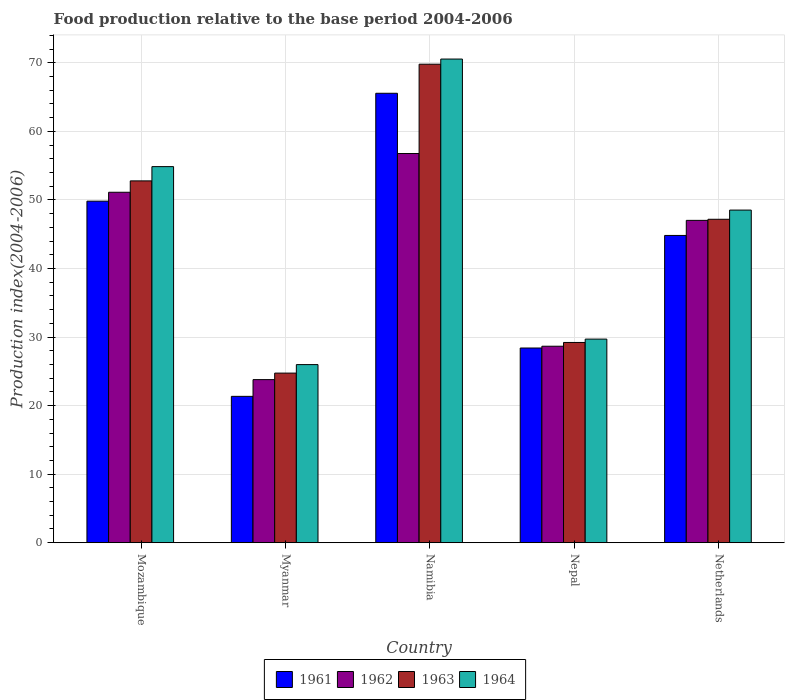How many groups of bars are there?
Give a very brief answer. 5. Are the number of bars on each tick of the X-axis equal?
Provide a short and direct response. Yes. How many bars are there on the 3rd tick from the right?
Your answer should be compact. 4. What is the label of the 5th group of bars from the left?
Your response must be concise. Netherlands. In how many cases, is the number of bars for a given country not equal to the number of legend labels?
Provide a succinct answer. 0. What is the food production index in 1961 in Myanmar?
Provide a succinct answer. 21.35. Across all countries, what is the maximum food production index in 1961?
Keep it short and to the point. 65.56. Across all countries, what is the minimum food production index in 1962?
Keep it short and to the point. 23.79. In which country was the food production index in 1963 maximum?
Your answer should be compact. Namibia. In which country was the food production index in 1962 minimum?
Provide a succinct answer. Myanmar. What is the total food production index in 1963 in the graph?
Offer a very short reply. 223.71. What is the difference between the food production index in 1963 in Namibia and that in Nepal?
Provide a short and direct response. 40.59. What is the difference between the food production index in 1964 in Mozambique and the food production index in 1962 in Namibia?
Ensure brevity in your answer.  -1.91. What is the average food production index in 1961 per country?
Provide a succinct answer. 41.99. What is the difference between the food production index of/in 1961 and food production index of/in 1962 in Nepal?
Your answer should be compact. -0.26. In how many countries, is the food production index in 1961 greater than 4?
Ensure brevity in your answer.  5. What is the ratio of the food production index in 1961 in Namibia to that in Nepal?
Offer a very short reply. 2.31. What is the difference between the highest and the second highest food production index in 1963?
Your response must be concise. -17.02. What is the difference between the highest and the lowest food production index in 1962?
Your response must be concise. 32.98. In how many countries, is the food production index in 1964 greater than the average food production index in 1964 taken over all countries?
Provide a succinct answer. 3. What does the 4th bar from the left in Namibia represents?
Your answer should be very brief. 1964. Is it the case that in every country, the sum of the food production index in 1964 and food production index in 1962 is greater than the food production index in 1961?
Your answer should be compact. Yes. Are all the bars in the graph horizontal?
Your answer should be very brief. No. What is the difference between two consecutive major ticks on the Y-axis?
Make the answer very short. 10. Are the values on the major ticks of Y-axis written in scientific E-notation?
Provide a short and direct response. No. Does the graph contain any zero values?
Provide a succinct answer. No. Does the graph contain grids?
Ensure brevity in your answer.  Yes. How many legend labels are there?
Ensure brevity in your answer.  4. What is the title of the graph?
Offer a very short reply. Food production relative to the base period 2004-2006. What is the label or title of the Y-axis?
Offer a very short reply. Production index(2004-2006). What is the Production index(2004-2006) of 1961 in Mozambique?
Provide a succinct answer. 49.82. What is the Production index(2004-2006) in 1962 in Mozambique?
Make the answer very short. 51.12. What is the Production index(2004-2006) in 1963 in Mozambique?
Your answer should be compact. 52.78. What is the Production index(2004-2006) in 1964 in Mozambique?
Provide a short and direct response. 54.86. What is the Production index(2004-2006) of 1961 in Myanmar?
Keep it short and to the point. 21.35. What is the Production index(2004-2006) in 1962 in Myanmar?
Offer a very short reply. 23.79. What is the Production index(2004-2006) in 1963 in Myanmar?
Give a very brief answer. 24.74. What is the Production index(2004-2006) of 1964 in Myanmar?
Offer a terse response. 25.98. What is the Production index(2004-2006) in 1961 in Namibia?
Keep it short and to the point. 65.56. What is the Production index(2004-2006) in 1962 in Namibia?
Provide a succinct answer. 56.77. What is the Production index(2004-2006) in 1963 in Namibia?
Offer a very short reply. 69.8. What is the Production index(2004-2006) in 1964 in Namibia?
Offer a very short reply. 70.55. What is the Production index(2004-2006) of 1961 in Nepal?
Give a very brief answer. 28.4. What is the Production index(2004-2006) of 1962 in Nepal?
Provide a succinct answer. 28.66. What is the Production index(2004-2006) in 1963 in Nepal?
Offer a very short reply. 29.21. What is the Production index(2004-2006) in 1964 in Nepal?
Offer a terse response. 29.7. What is the Production index(2004-2006) in 1961 in Netherlands?
Provide a succinct answer. 44.82. What is the Production index(2004-2006) in 1962 in Netherlands?
Your answer should be very brief. 47.02. What is the Production index(2004-2006) in 1963 in Netherlands?
Your response must be concise. 47.18. What is the Production index(2004-2006) of 1964 in Netherlands?
Provide a short and direct response. 48.52. Across all countries, what is the maximum Production index(2004-2006) of 1961?
Ensure brevity in your answer.  65.56. Across all countries, what is the maximum Production index(2004-2006) in 1962?
Provide a short and direct response. 56.77. Across all countries, what is the maximum Production index(2004-2006) of 1963?
Provide a succinct answer. 69.8. Across all countries, what is the maximum Production index(2004-2006) of 1964?
Make the answer very short. 70.55. Across all countries, what is the minimum Production index(2004-2006) of 1961?
Ensure brevity in your answer.  21.35. Across all countries, what is the minimum Production index(2004-2006) of 1962?
Ensure brevity in your answer.  23.79. Across all countries, what is the minimum Production index(2004-2006) of 1963?
Give a very brief answer. 24.74. Across all countries, what is the minimum Production index(2004-2006) in 1964?
Your response must be concise. 25.98. What is the total Production index(2004-2006) in 1961 in the graph?
Ensure brevity in your answer.  209.95. What is the total Production index(2004-2006) in 1962 in the graph?
Your answer should be very brief. 207.36. What is the total Production index(2004-2006) in 1963 in the graph?
Provide a short and direct response. 223.71. What is the total Production index(2004-2006) of 1964 in the graph?
Offer a very short reply. 229.61. What is the difference between the Production index(2004-2006) in 1961 in Mozambique and that in Myanmar?
Your answer should be compact. 28.47. What is the difference between the Production index(2004-2006) in 1962 in Mozambique and that in Myanmar?
Ensure brevity in your answer.  27.33. What is the difference between the Production index(2004-2006) in 1963 in Mozambique and that in Myanmar?
Provide a succinct answer. 28.04. What is the difference between the Production index(2004-2006) of 1964 in Mozambique and that in Myanmar?
Your answer should be compact. 28.88. What is the difference between the Production index(2004-2006) of 1961 in Mozambique and that in Namibia?
Your answer should be very brief. -15.74. What is the difference between the Production index(2004-2006) in 1962 in Mozambique and that in Namibia?
Give a very brief answer. -5.65. What is the difference between the Production index(2004-2006) in 1963 in Mozambique and that in Namibia?
Your answer should be very brief. -17.02. What is the difference between the Production index(2004-2006) in 1964 in Mozambique and that in Namibia?
Provide a succinct answer. -15.69. What is the difference between the Production index(2004-2006) of 1961 in Mozambique and that in Nepal?
Your answer should be compact. 21.42. What is the difference between the Production index(2004-2006) of 1962 in Mozambique and that in Nepal?
Ensure brevity in your answer.  22.46. What is the difference between the Production index(2004-2006) of 1963 in Mozambique and that in Nepal?
Provide a succinct answer. 23.57. What is the difference between the Production index(2004-2006) of 1964 in Mozambique and that in Nepal?
Keep it short and to the point. 25.16. What is the difference between the Production index(2004-2006) of 1962 in Mozambique and that in Netherlands?
Keep it short and to the point. 4.1. What is the difference between the Production index(2004-2006) in 1963 in Mozambique and that in Netherlands?
Your answer should be very brief. 5.6. What is the difference between the Production index(2004-2006) in 1964 in Mozambique and that in Netherlands?
Give a very brief answer. 6.34. What is the difference between the Production index(2004-2006) of 1961 in Myanmar and that in Namibia?
Your answer should be very brief. -44.21. What is the difference between the Production index(2004-2006) of 1962 in Myanmar and that in Namibia?
Offer a terse response. -32.98. What is the difference between the Production index(2004-2006) of 1963 in Myanmar and that in Namibia?
Your answer should be very brief. -45.06. What is the difference between the Production index(2004-2006) in 1964 in Myanmar and that in Namibia?
Your answer should be very brief. -44.57. What is the difference between the Production index(2004-2006) of 1961 in Myanmar and that in Nepal?
Your answer should be very brief. -7.05. What is the difference between the Production index(2004-2006) of 1962 in Myanmar and that in Nepal?
Offer a very short reply. -4.87. What is the difference between the Production index(2004-2006) in 1963 in Myanmar and that in Nepal?
Your response must be concise. -4.47. What is the difference between the Production index(2004-2006) in 1964 in Myanmar and that in Nepal?
Provide a succinct answer. -3.72. What is the difference between the Production index(2004-2006) of 1961 in Myanmar and that in Netherlands?
Your response must be concise. -23.47. What is the difference between the Production index(2004-2006) in 1962 in Myanmar and that in Netherlands?
Keep it short and to the point. -23.23. What is the difference between the Production index(2004-2006) in 1963 in Myanmar and that in Netherlands?
Provide a short and direct response. -22.44. What is the difference between the Production index(2004-2006) of 1964 in Myanmar and that in Netherlands?
Keep it short and to the point. -22.54. What is the difference between the Production index(2004-2006) in 1961 in Namibia and that in Nepal?
Offer a very short reply. 37.16. What is the difference between the Production index(2004-2006) of 1962 in Namibia and that in Nepal?
Keep it short and to the point. 28.11. What is the difference between the Production index(2004-2006) in 1963 in Namibia and that in Nepal?
Your answer should be very brief. 40.59. What is the difference between the Production index(2004-2006) of 1964 in Namibia and that in Nepal?
Your answer should be very brief. 40.85. What is the difference between the Production index(2004-2006) of 1961 in Namibia and that in Netherlands?
Your answer should be compact. 20.74. What is the difference between the Production index(2004-2006) in 1962 in Namibia and that in Netherlands?
Your answer should be compact. 9.75. What is the difference between the Production index(2004-2006) of 1963 in Namibia and that in Netherlands?
Provide a short and direct response. 22.62. What is the difference between the Production index(2004-2006) in 1964 in Namibia and that in Netherlands?
Make the answer very short. 22.03. What is the difference between the Production index(2004-2006) of 1961 in Nepal and that in Netherlands?
Your answer should be very brief. -16.42. What is the difference between the Production index(2004-2006) in 1962 in Nepal and that in Netherlands?
Your answer should be very brief. -18.36. What is the difference between the Production index(2004-2006) of 1963 in Nepal and that in Netherlands?
Offer a terse response. -17.97. What is the difference between the Production index(2004-2006) of 1964 in Nepal and that in Netherlands?
Provide a succinct answer. -18.82. What is the difference between the Production index(2004-2006) in 1961 in Mozambique and the Production index(2004-2006) in 1962 in Myanmar?
Your response must be concise. 26.03. What is the difference between the Production index(2004-2006) in 1961 in Mozambique and the Production index(2004-2006) in 1963 in Myanmar?
Keep it short and to the point. 25.08. What is the difference between the Production index(2004-2006) of 1961 in Mozambique and the Production index(2004-2006) of 1964 in Myanmar?
Offer a very short reply. 23.84. What is the difference between the Production index(2004-2006) of 1962 in Mozambique and the Production index(2004-2006) of 1963 in Myanmar?
Offer a very short reply. 26.38. What is the difference between the Production index(2004-2006) of 1962 in Mozambique and the Production index(2004-2006) of 1964 in Myanmar?
Your answer should be very brief. 25.14. What is the difference between the Production index(2004-2006) in 1963 in Mozambique and the Production index(2004-2006) in 1964 in Myanmar?
Give a very brief answer. 26.8. What is the difference between the Production index(2004-2006) of 1961 in Mozambique and the Production index(2004-2006) of 1962 in Namibia?
Your response must be concise. -6.95. What is the difference between the Production index(2004-2006) of 1961 in Mozambique and the Production index(2004-2006) of 1963 in Namibia?
Offer a terse response. -19.98. What is the difference between the Production index(2004-2006) in 1961 in Mozambique and the Production index(2004-2006) in 1964 in Namibia?
Your answer should be compact. -20.73. What is the difference between the Production index(2004-2006) in 1962 in Mozambique and the Production index(2004-2006) in 1963 in Namibia?
Keep it short and to the point. -18.68. What is the difference between the Production index(2004-2006) in 1962 in Mozambique and the Production index(2004-2006) in 1964 in Namibia?
Your response must be concise. -19.43. What is the difference between the Production index(2004-2006) of 1963 in Mozambique and the Production index(2004-2006) of 1964 in Namibia?
Make the answer very short. -17.77. What is the difference between the Production index(2004-2006) in 1961 in Mozambique and the Production index(2004-2006) in 1962 in Nepal?
Make the answer very short. 21.16. What is the difference between the Production index(2004-2006) in 1961 in Mozambique and the Production index(2004-2006) in 1963 in Nepal?
Your answer should be very brief. 20.61. What is the difference between the Production index(2004-2006) of 1961 in Mozambique and the Production index(2004-2006) of 1964 in Nepal?
Make the answer very short. 20.12. What is the difference between the Production index(2004-2006) in 1962 in Mozambique and the Production index(2004-2006) in 1963 in Nepal?
Offer a terse response. 21.91. What is the difference between the Production index(2004-2006) of 1962 in Mozambique and the Production index(2004-2006) of 1964 in Nepal?
Provide a short and direct response. 21.42. What is the difference between the Production index(2004-2006) in 1963 in Mozambique and the Production index(2004-2006) in 1964 in Nepal?
Give a very brief answer. 23.08. What is the difference between the Production index(2004-2006) of 1961 in Mozambique and the Production index(2004-2006) of 1962 in Netherlands?
Provide a short and direct response. 2.8. What is the difference between the Production index(2004-2006) in 1961 in Mozambique and the Production index(2004-2006) in 1963 in Netherlands?
Your answer should be compact. 2.64. What is the difference between the Production index(2004-2006) in 1962 in Mozambique and the Production index(2004-2006) in 1963 in Netherlands?
Your answer should be compact. 3.94. What is the difference between the Production index(2004-2006) in 1962 in Mozambique and the Production index(2004-2006) in 1964 in Netherlands?
Give a very brief answer. 2.6. What is the difference between the Production index(2004-2006) in 1963 in Mozambique and the Production index(2004-2006) in 1964 in Netherlands?
Provide a succinct answer. 4.26. What is the difference between the Production index(2004-2006) in 1961 in Myanmar and the Production index(2004-2006) in 1962 in Namibia?
Keep it short and to the point. -35.42. What is the difference between the Production index(2004-2006) in 1961 in Myanmar and the Production index(2004-2006) in 1963 in Namibia?
Keep it short and to the point. -48.45. What is the difference between the Production index(2004-2006) in 1961 in Myanmar and the Production index(2004-2006) in 1964 in Namibia?
Keep it short and to the point. -49.2. What is the difference between the Production index(2004-2006) in 1962 in Myanmar and the Production index(2004-2006) in 1963 in Namibia?
Your answer should be very brief. -46.01. What is the difference between the Production index(2004-2006) in 1962 in Myanmar and the Production index(2004-2006) in 1964 in Namibia?
Keep it short and to the point. -46.76. What is the difference between the Production index(2004-2006) in 1963 in Myanmar and the Production index(2004-2006) in 1964 in Namibia?
Your response must be concise. -45.81. What is the difference between the Production index(2004-2006) of 1961 in Myanmar and the Production index(2004-2006) of 1962 in Nepal?
Give a very brief answer. -7.31. What is the difference between the Production index(2004-2006) of 1961 in Myanmar and the Production index(2004-2006) of 1963 in Nepal?
Your answer should be compact. -7.86. What is the difference between the Production index(2004-2006) in 1961 in Myanmar and the Production index(2004-2006) in 1964 in Nepal?
Your response must be concise. -8.35. What is the difference between the Production index(2004-2006) of 1962 in Myanmar and the Production index(2004-2006) of 1963 in Nepal?
Give a very brief answer. -5.42. What is the difference between the Production index(2004-2006) in 1962 in Myanmar and the Production index(2004-2006) in 1964 in Nepal?
Give a very brief answer. -5.91. What is the difference between the Production index(2004-2006) of 1963 in Myanmar and the Production index(2004-2006) of 1964 in Nepal?
Make the answer very short. -4.96. What is the difference between the Production index(2004-2006) of 1961 in Myanmar and the Production index(2004-2006) of 1962 in Netherlands?
Ensure brevity in your answer.  -25.67. What is the difference between the Production index(2004-2006) of 1961 in Myanmar and the Production index(2004-2006) of 1963 in Netherlands?
Your response must be concise. -25.83. What is the difference between the Production index(2004-2006) of 1961 in Myanmar and the Production index(2004-2006) of 1964 in Netherlands?
Offer a terse response. -27.17. What is the difference between the Production index(2004-2006) in 1962 in Myanmar and the Production index(2004-2006) in 1963 in Netherlands?
Your answer should be compact. -23.39. What is the difference between the Production index(2004-2006) in 1962 in Myanmar and the Production index(2004-2006) in 1964 in Netherlands?
Your answer should be very brief. -24.73. What is the difference between the Production index(2004-2006) in 1963 in Myanmar and the Production index(2004-2006) in 1964 in Netherlands?
Provide a succinct answer. -23.78. What is the difference between the Production index(2004-2006) in 1961 in Namibia and the Production index(2004-2006) in 1962 in Nepal?
Keep it short and to the point. 36.9. What is the difference between the Production index(2004-2006) of 1961 in Namibia and the Production index(2004-2006) of 1963 in Nepal?
Your answer should be very brief. 36.35. What is the difference between the Production index(2004-2006) in 1961 in Namibia and the Production index(2004-2006) in 1964 in Nepal?
Your answer should be very brief. 35.86. What is the difference between the Production index(2004-2006) of 1962 in Namibia and the Production index(2004-2006) of 1963 in Nepal?
Your answer should be compact. 27.56. What is the difference between the Production index(2004-2006) in 1962 in Namibia and the Production index(2004-2006) in 1964 in Nepal?
Keep it short and to the point. 27.07. What is the difference between the Production index(2004-2006) in 1963 in Namibia and the Production index(2004-2006) in 1964 in Nepal?
Your answer should be very brief. 40.1. What is the difference between the Production index(2004-2006) in 1961 in Namibia and the Production index(2004-2006) in 1962 in Netherlands?
Your answer should be compact. 18.54. What is the difference between the Production index(2004-2006) of 1961 in Namibia and the Production index(2004-2006) of 1963 in Netherlands?
Your answer should be very brief. 18.38. What is the difference between the Production index(2004-2006) of 1961 in Namibia and the Production index(2004-2006) of 1964 in Netherlands?
Give a very brief answer. 17.04. What is the difference between the Production index(2004-2006) of 1962 in Namibia and the Production index(2004-2006) of 1963 in Netherlands?
Your answer should be very brief. 9.59. What is the difference between the Production index(2004-2006) in 1962 in Namibia and the Production index(2004-2006) in 1964 in Netherlands?
Give a very brief answer. 8.25. What is the difference between the Production index(2004-2006) in 1963 in Namibia and the Production index(2004-2006) in 1964 in Netherlands?
Give a very brief answer. 21.28. What is the difference between the Production index(2004-2006) of 1961 in Nepal and the Production index(2004-2006) of 1962 in Netherlands?
Offer a very short reply. -18.62. What is the difference between the Production index(2004-2006) of 1961 in Nepal and the Production index(2004-2006) of 1963 in Netherlands?
Keep it short and to the point. -18.78. What is the difference between the Production index(2004-2006) of 1961 in Nepal and the Production index(2004-2006) of 1964 in Netherlands?
Keep it short and to the point. -20.12. What is the difference between the Production index(2004-2006) of 1962 in Nepal and the Production index(2004-2006) of 1963 in Netherlands?
Make the answer very short. -18.52. What is the difference between the Production index(2004-2006) of 1962 in Nepal and the Production index(2004-2006) of 1964 in Netherlands?
Offer a terse response. -19.86. What is the difference between the Production index(2004-2006) of 1963 in Nepal and the Production index(2004-2006) of 1964 in Netherlands?
Make the answer very short. -19.31. What is the average Production index(2004-2006) of 1961 per country?
Provide a short and direct response. 41.99. What is the average Production index(2004-2006) of 1962 per country?
Your answer should be very brief. 41.47. What is the average Production index(2004-2006) of 1963 per country?
Provide a short and direct response. 44.74. What is the average Production index(2004-2006) in 1964 per country?
Your response must be concise. 45.92. What is the difference between the Production index(2004-2006) in 1961 and Production index(2004-2006) in 1962 in Mozambique?
Ensure brevity in your answer.  -1.3. What is the difference between the Production index(2004-2006) in 1961 and Production index(2004-2006) in 1963 in Mozambique?
Ensure brevity in your answer.  -2.96. What is the difference between the Production index(2004-2006) in 1961 and Production index(2004-2006) in 1964 in Mozambique?
Your response must be concise. -5.04. What is the difference between the Production index(2004-2006) of 1962 and Production index(2004-2006) of 1963 in Mozambique?
Keep it short and to the point. -1.66. What is the difference between the Production index(2004-2006) in 1962 and Production index(2004-2006) in 1964 in Mozambique?
Your answer should be very brief. -3.74. What is the difference between the Production index(2004-2006) in 1963 and Production index(2004-2006) in 1964 in Mozambique?
Provide a short and direct response. -2.08. What is the difference between the Production index(2004-2006) in 1961 and Production index(2004-2006) in 1962 in Myanmar?
Your answer should be compact. -2.44. What is the difference between the Production index(2004-2006) in 1961 and Production index(2004-2006) in 1963 in Myanmar?
Provide a succinct answer. -3.39. What is the difference between the Production index(2004-2006) of 1961 and Production index(2004-2006) of 1964 in Myanmar?
Your response must be concise. -4.63. What is the difference between the Production index(2004-2006) of 1962 and Production index(2004-2006) of 1963 in Myanmar?
Offer a very short reply. -0.95. What is the difference between the Production index(2004-2006) of 1962 and Production index(2004-2006) of 1964 in Myanmar?
Keep it short and to the point. -2.19. What is the difference between the Production index(2004-2006) of 1963 and Production index(2004-2006) of 1964 in Myanmar?
Provide a succinct answer. -1.24. What is the difference between the Production index(2004-2006) in 1961 and Production index(2004-2006) in 1962 in Namibia?
Your answer should be compact. 8.79. What is the difference between the Production index(2004-2006) in 1961 and Production index(2004-2006) in 1963 in Namibia?
Provide a succinct answer. -4.24. What is the difference between the Production index(2004-2006) in 1961 and Production index(2004-2006) in 1964 in Namibia?
Keep it short and to the point. -4.99. What is the difference between the Production index(2004-2006) in 1962 and Production index(2004-2006) in 1963 in Namibia?
Your answer should be compact. -13.03. What is the difference between the Production index(2004-2006) of 1962 and Production index(2004-2006) of 1964 in Namibia?
Ensure brevity in your answer.  -13.78. What is the difference between the Production index(2004-2006) of 1963 and Production index(2004-2006) of 1964 in Namibia?
Your response must be concise. -0.75. What is the difference between the Production index(2004-2006) of 1961 and Production index(2004-2006) of 1962 in Nepal?
Ensure brevity in your answer.  -0.26. What is the difference between the Production index(2004-2006) in 1961 and Production index(2004-2006) in 1963 in Nepal?
Keep it short and to the point. -0.81. What is the difference between the Production index(2004-2006) in 1962 and Production index(2004-2006) in 1963 in Nepal?
Your answer should be compact. -0.55. What is the difference between the Production index(2004-2006) of 1962 and Production index(2004-2006) of 1964 in Nepal?
Your response must be concise. -1.04. What is the difference between the Production index(2004-2006) of 1963 and Production index(2004-2006) of 1964 in Nepal?
Your response must be concise. -0.49. What is the difference between the Production index(2004-2006) of 1961 and Production index(2004-2006) of 1962 in Netherlands?
Keep it short and to the point. -2.2. What is the difference between the Production index(2004-2006) of 1961 and Production index(2004-2006) of 1963 in Netherlands?
Your answer should be very brief. -2.36. What is the difference between the Production index(2004-2006) of 1962 and Production index(2004-2006) of 1963 in Netherlands?
Your answer should be very brief. -0.16. What is the difference between the Production index(2004-2006) in 1962 and Production index(2004-2006) in 1964 in Netherlands?
Provide a succinct answer. -1.5. What is the difference between the Production index(2004-2006) in 1963 and Production index(2004-2006) in 1964 in Netherlands?
Your answer should be very brief. -1.34. What is the ratio of the Production index(2004-2006) of 1961 in Mozambique to that in Myanmar?
Give a very brief answer. 2.33. What is the ratio of the Production index(2004-2006) of 1962 in Mozambique to that in Myanmar?
Give a very brief answer. 2.15. What is the ratio of the Production index(2004-2006) of 1963 in Mozambique to that in Myanmar?
Ensure brevity in your answer.  2.13. What is the ratio of the Production index(2004-2006) of 1964 in Mozambique to that in Myanmar?
Your response must be concise. 2.11. What is the ratio of the Production index(2004-2006) of 1961 in Mozambique to that in Namibia?
Ensure brevity in your answer.  0.76. What is the ratio of the Production index(2004-2006) in 1962 in Mozambique to that in Namibia?
Your response must be concise. 0.9. What is the ratio of the Production index(2004-2006) in 1963 in Mozambique to that in Namibia?
Keep it short and to the point. 0.76. What is the ratio of the Production index(2004-2006) in 1964 in Mozambique to that in Namibia?
Offer a terse response. 0.78. What is the ratio of the Production index(2004-2006) of 1961 in Mozambique to that in Nepal?
Provide a short and direct response. 1.75. What is the ratio of the Production index(2004-2006) in 1962 in Mozambique to that in Nepal?
Provide a short and direct response. 1.78. What is the ratio of the Production index(2004-2006) in 1963 in Mozambique to that in Nepal?
Offer a very short reply. 1.81. What is the ratio of the Production index(2004-2006) of 1964 in Mozambique to that in Nepal?
Make the answer very short. 1.85. What is the ratio of the Production index(2004-2006) in 1961 in Mozambique to that in Netherlands?
Give a very brief answer. 1.11. What is the ratio of the Production index(2004-2006) in 1962 in Mozambique to that in Netherlands?
Ensure brevity in your answer.  1.09. What is the ratio of the Production index(2004-2006) of 1963 in Mozambique to that in Netherlands?
Keep it short and to the point. 1.12. What is the ratio of the Production index(2004-2006) of 1964 in Mozambique to that in Netherlands?
Provide a succinct answer. 1.13. What is the ratio of the Production index(2004-2006) of 1961 in Myanmar to that in Namibia?
Offer a terse response. 0.33. What is the ratio of the Production index(2004-2006) of 1962 in Myanmar to that in Namibia?
Provide a short and direct response. 0.42. What is the ratio of the Production index(2004-2006) of 1963 in Myanmar to that in Namibia?
Your answer should be compact. 0.35. What is the ratio of the Production index(2004-2006) in 1964 in Myanmar to that in Namibia?
Ensure brevity in your answer.  0.37. What is the ratio of the Production index(2004-2006) in 1961 in Myanmar to that in Nepal?
Keep it short and to the point. 0.75. What is the ratio of the Production index(2004-2006) of 1962 in Myanmar to that in Nepal?
Offer a very short reply. 0.83. What is the ratio of the Production index(2004-2006) of 1963 in Myanmar to that in Nepal?
Your answer should be very brief. 0.85. What is the ratio of the Production index(2004-2006) of 1964 in Myanmar to that in Nepal?
Give a very brief answer. 0.87. What is the ratio of the Production index(2004-2006) of 1961 in Myanmar to that in Netherlands?
Keep it short and to the point. 0.48. What is the ratio of the Production index(2004-2006) of 1962 in Myanmar to that in Netherlands?
Your answer should be compact. 0.51. What is the ratio of the Production index(2004-2006) in 1963 in Myanmar to that in Netherlands?
Offer a terse response. 0.52. What is the ratio of the Production index(2004-2006) of 1964 in Myanmar to that in Netherlands?
Give a very brief answer. 0.54. What is the ratio of the Production index(2004-2006) of 1961 in Namibia to that in Nepal?
Offer a very short reply. 2.31. What is the ratio of the Production index(2004-2006) of 1962 in Namibia to that in Nepal?
Your response must be concise. 1.98. What is the ratio of the Production index(2004-2006) of 1963 in Namibia to that in Nepal?
Provide a succinct answer. 2.39. What is the ratio of the Production index(2004-2006) in 1964 in Namibia to that in Nepal?
Offer a terse response. 2.38. What is the ratio of the Production index(2004-2006) of 1961 in Namibia to that in Netherlands?
Ensure brevity in your answer.  1.46. What is the ratio of the Production index(2004-2006) of 1962 in Namibia to that in Netherlands?
Your answer should be very brief. 1.21. What is the ratio of the Production index(2004-2006) in 1963 in Namibia to that in Netherlands?
Give a very brief answer. 1.48. What is the ratio of the Production index(2004-2006) in 1964 in Namibia to that in Netherlands?
Offer a very short reply. 1.45. What is the ratio of the Production index(2004-2006) in 1961 in Nepal to that in Netherlands?
Keep it short and to the point. 0.63. What is the ratio of the Production index(2004-2006) of 1962 in Nepal to that in Netherlands?
Your response must be concise. 0.61. What is the ratio of the Production index(2004-2006) of 1963 in Nepal to that in Netherlands?
Your answer should be compact. 0.62. What is the ratio of the Production index(2004-2006) of 1964 in Nepal to that in Netherlands?
Provide a short and direct response. 0.61. What is the difference between the highest and the second highest Production index(2004-2006) in 1961?
Offer a terse response. 15.74. What is the difference between the highest and the second highest Production index(2004-2006) of 1962?
Offer a terse response. 5.65. What is the difference between the highest and the second highest Production index(2004-2006) in 1963?
Ensure brevity in your answer.  17.02. What is the difference between the highest and the second highest Production index(2004-2006) of 1964?
Your response must be concise. 15.69. What is the difference between the highest and the lowest Production index(2004-2006) of 1961?
Offer a terse response. 44.21. What is the difference between the highest and the lowest Production index(2004-2006) of 1962?
Offer a terse response. 32.98. What is the difference between the highest and the lowest Production index(2004-2006) of 1963?
Keep it short and to the point. 45.06. What is the difference between the highest and the lowest Production index(2004-2006) in 1964?
Make the answer very short. 44.57. 